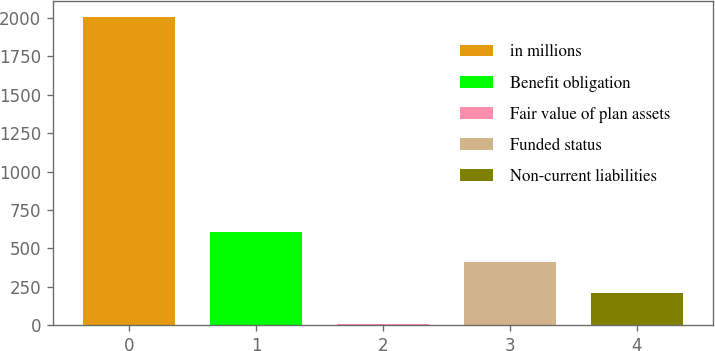Convert chart. <chart><loc_0><loc_0><loc_500><loc_500><bar_chart><fcel>in millions<fcel>Benefit obligation<fcel>Fair value of plan assets<fcel>Funded status<fcel>Non-current liabilities<nl><fcel>2010<fcel>608.67<fcel>8.1<fcel>408.48<fcel>208.29<nl></chart> 